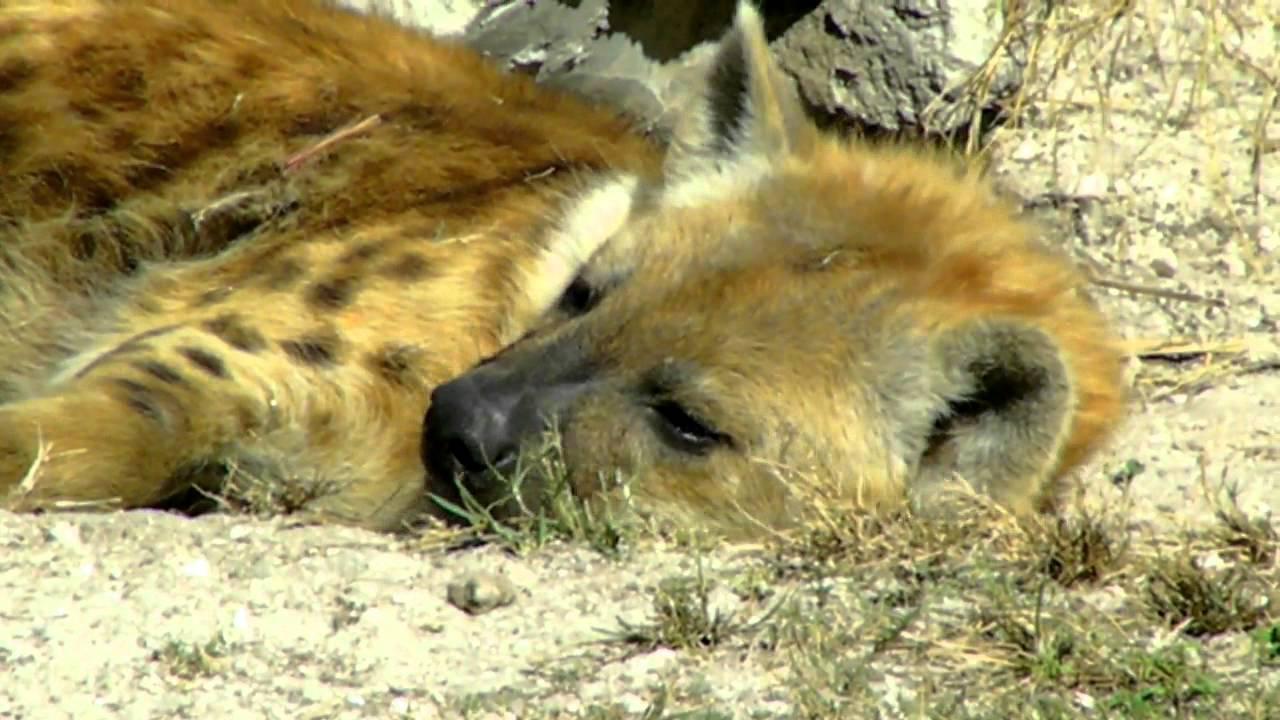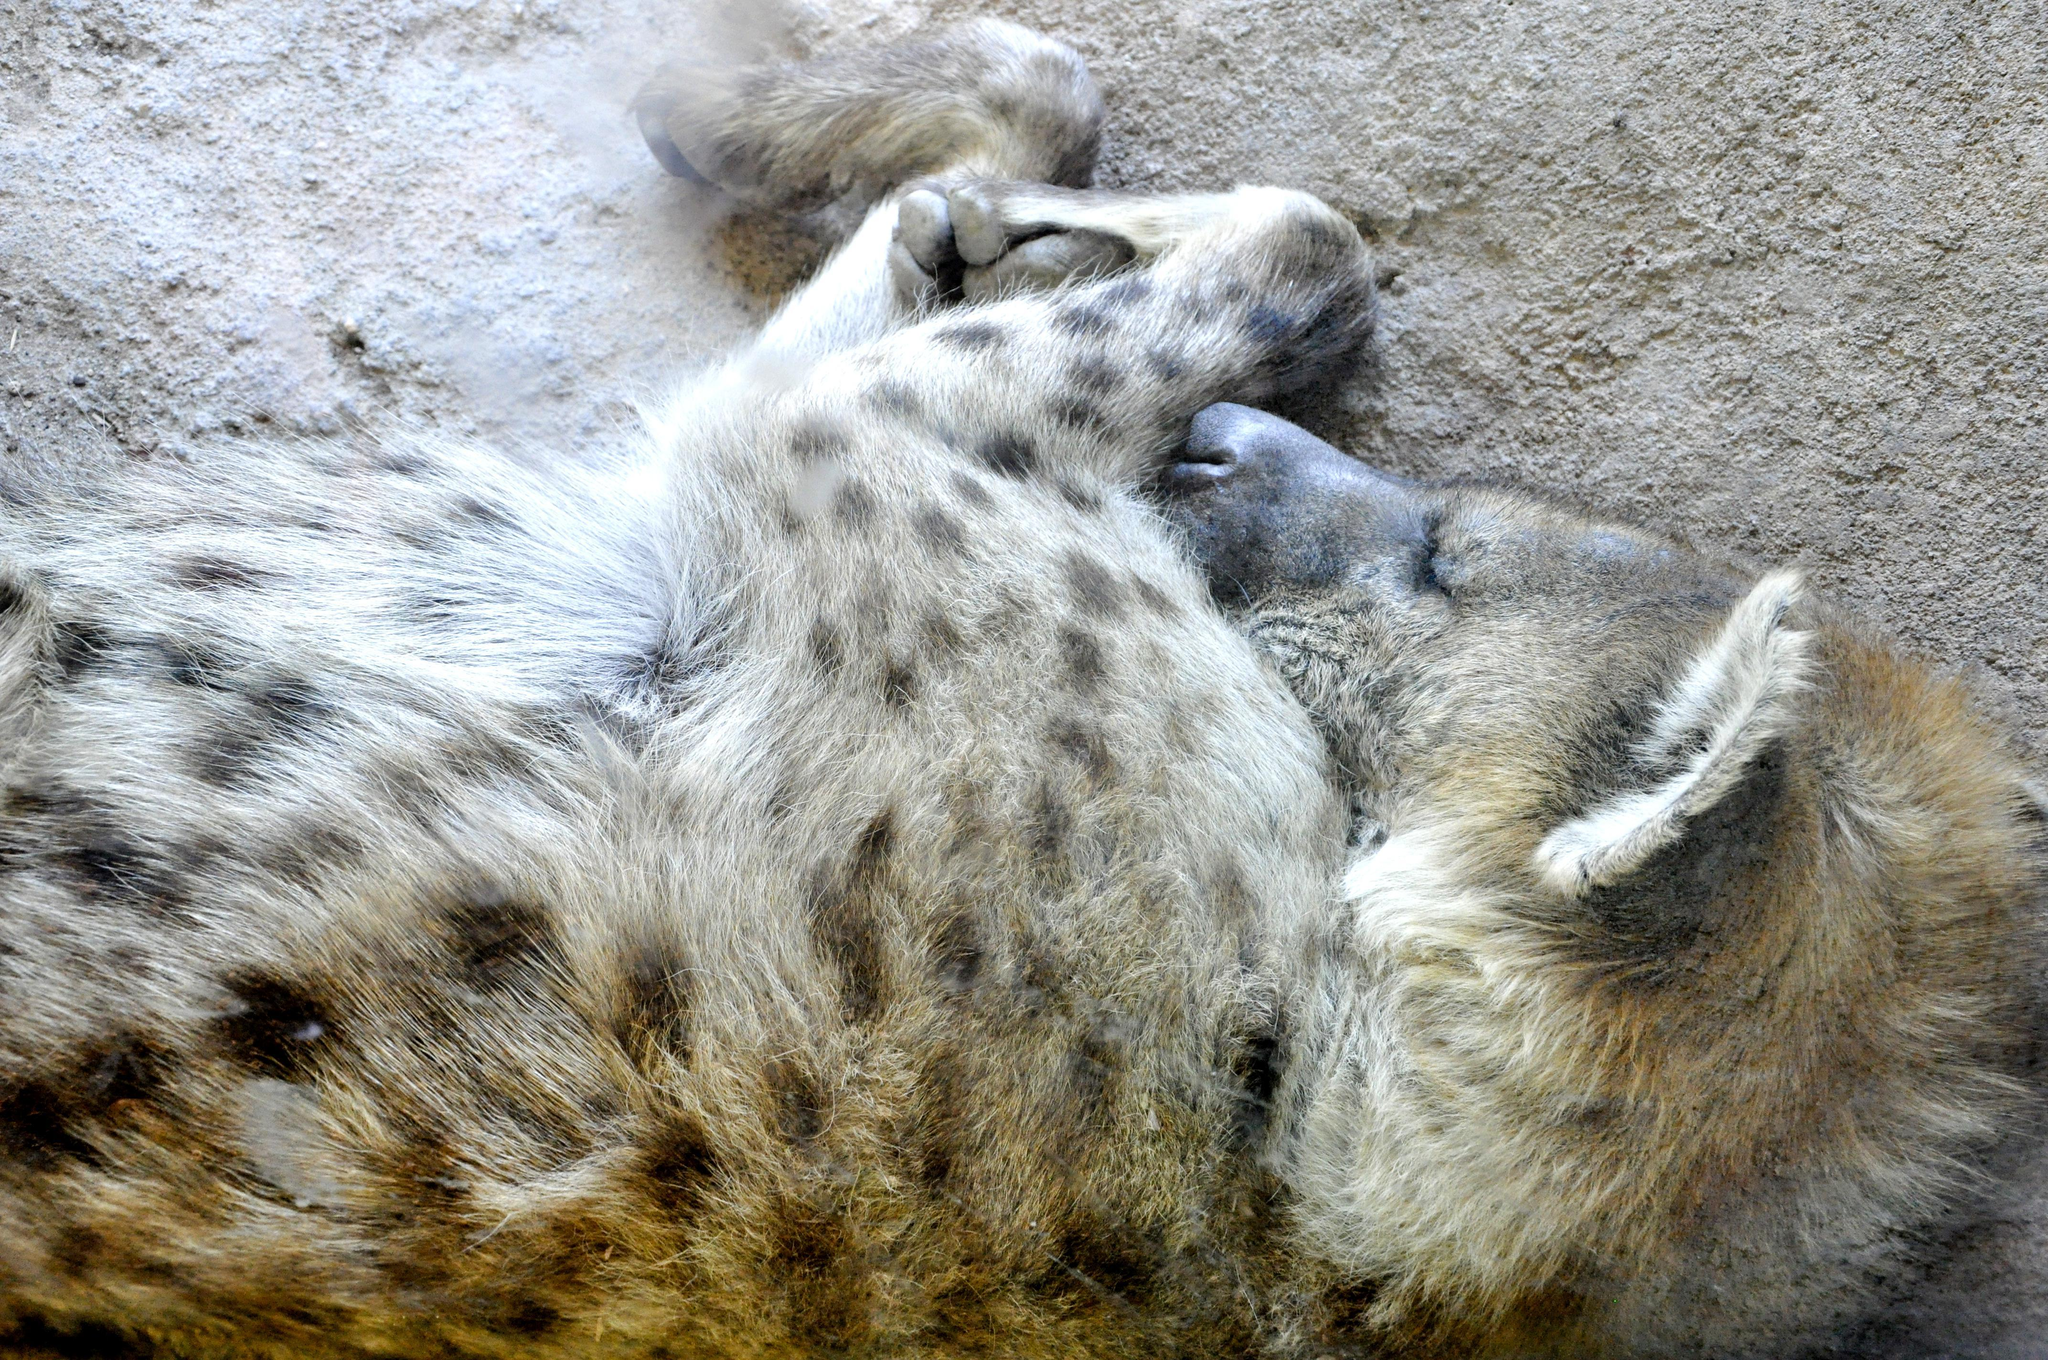The first image is the image on the left, the second image is the image on the right. Assess this claim about the two images: "A hyena is laying on another hyena.". Correct or not? Answer yes or no. No. The first image is the image on the left, the second image is the image on the right. Examine the images to the left and right. Is the description "Each image shows a reclining hyena with its body turned forward, and the right image features a reclining adult hyena with at least one hyena pup draped over it." accurate? Answer yes or no. No. 